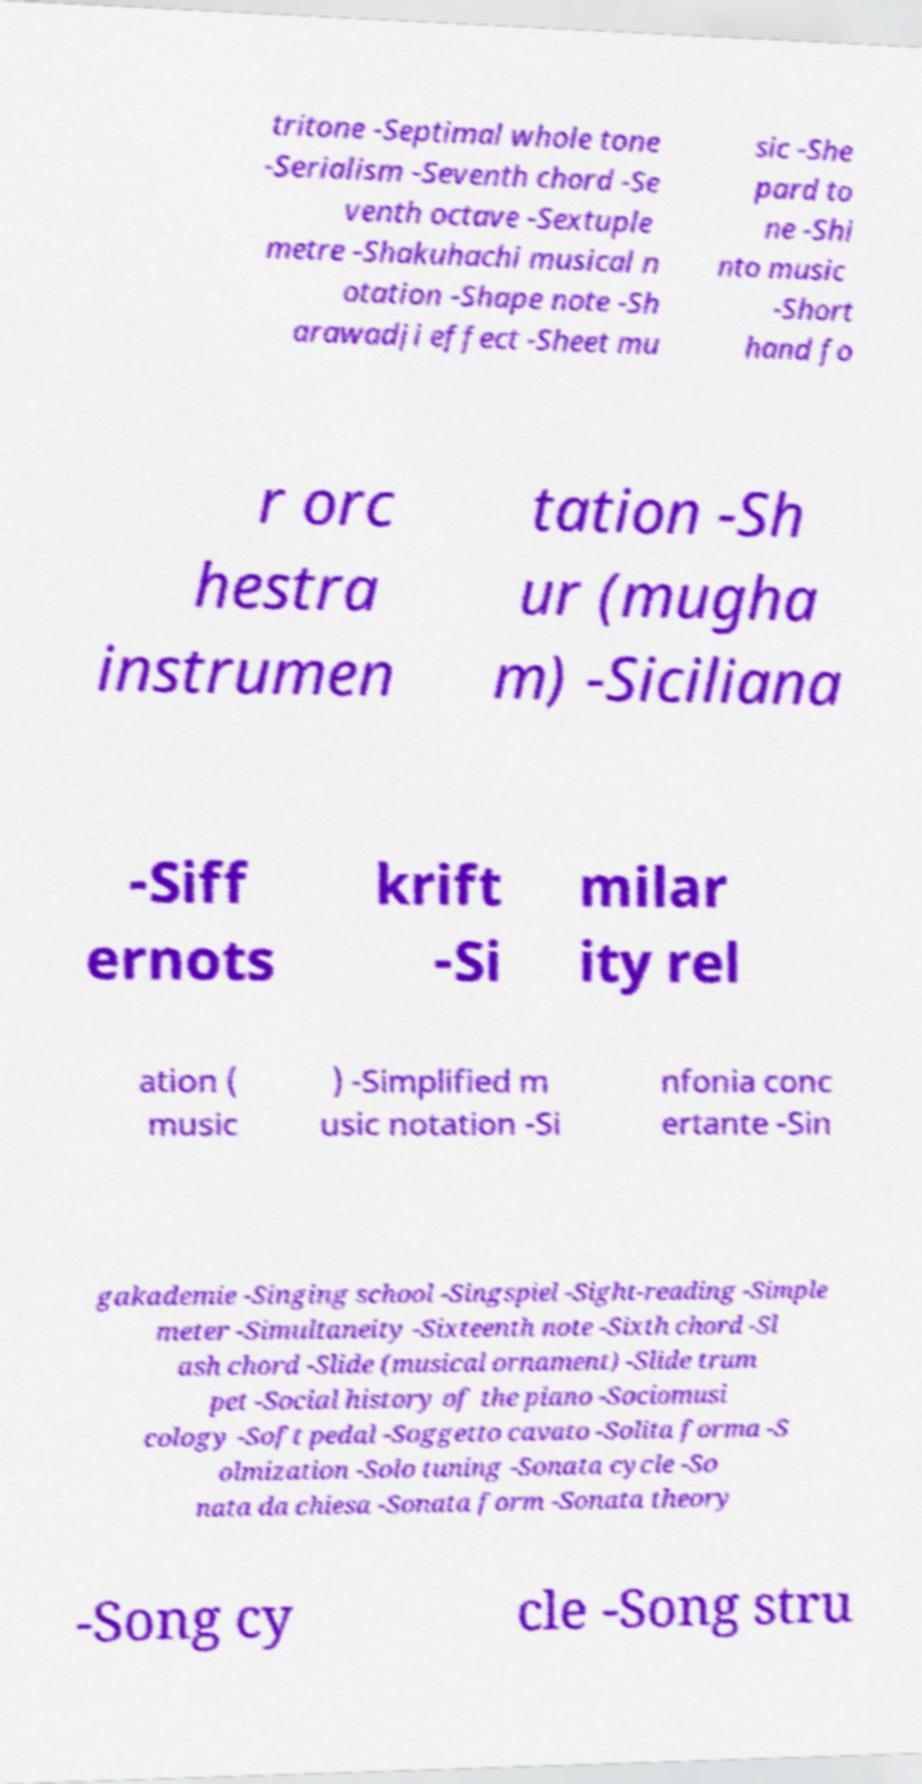For documentation purposes, I need the text within this image transcribed. Could you provide that? tritone -Septimal whole tone -Serialism -Seventh chord -Se venth octave -Sextuple metre -Shakuhachi musical n otation -Shape note -Sh arawadji effect -Sheet mu sic -She pard to ne -Shi nto music -Short hand fo r orc hestra instrumen tation -Sh ur (mugha m) -Siciliana -Siff ernots krift -Si milar ity rel ation ( music ) -Simplified m usic notation -Si nfonia conc ertante -Sin gakademie -Singing school -Singspiel -Sight-reading -Simple meter -Simultaneity -Sixteenth note -Sixth chord -Sl ash chord -Slide (musical ornament) -Slide trum pet -Social history of the piano -Sociomusi cology -Soft pedal -Soggetto cavato -Solita forma -S olmization -Solo tuning -Sonata cycle -So nata da chiesa -Sonata form -Sonata theory -Song cy cle -Song stru 